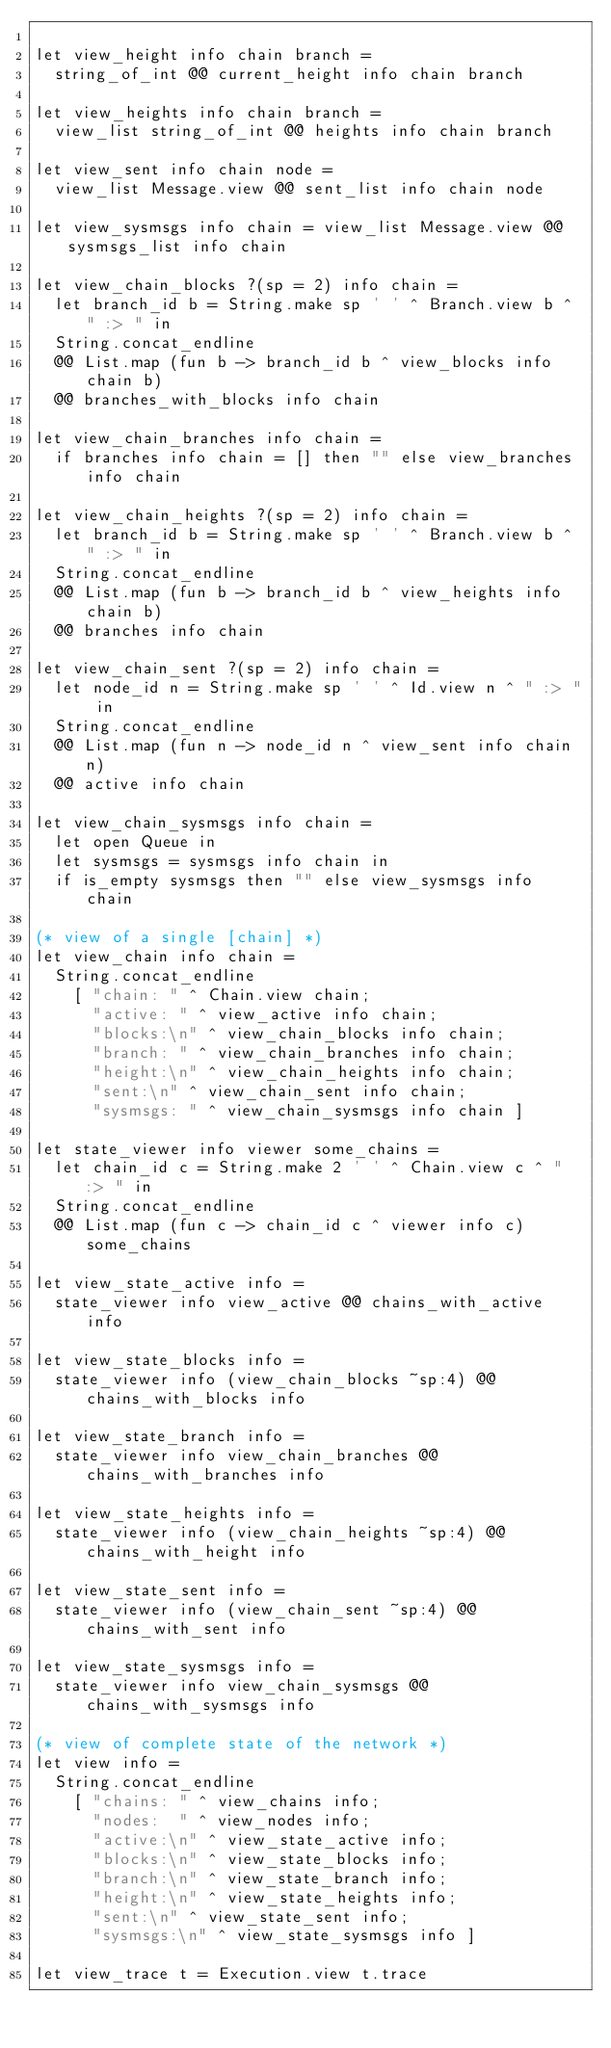<code> <loc_0><loc_0><loc_500><loc_500><_OCaml_>
let view_height info chain branch =
  string_of_int @@ current_height info chain branch

let view_heights info chain branch =
  view_list string_of_int @@ heights info chain branch

let view_sent info chain node =
  view_list Message.view @@ sent_list info chain node

let view_sysmsgs info chain = view_list Message.view @@ sysmsgs_list info chain

let view_chain_blocks ?(sp = 2) info chain =
  let branch_id b = String.make sp ' ' ^ Branch.view b ^ " :> " in
  String.concat_endline
  @@ List.map (fun b -> branch_id b ^ view_blocks info chain b)
  @@ branches_with_blocks info chain

let view_chain_branches info chain =
  if branches info chain = [] then "" else view_branches info chain

let view_chain_heights ?(sp = 2) info chain =
  let branch_id b = String.make sp ' ' ^ Branch.view b ^ " :> " in
  String.concat_endline
  @@ List.map (fun b -> branch_id b ^ view_heights info chain b)
  @@ branches info chain

let view_chain_sent ?(sp = 2) info chain =
  let node_id n = String.make sp ' ' ^ Id.view n ^ " :> " in
  String.concat_endline
  @@ List.map (fun n -> node_id n ^ view_sent info chain n)
  @@ active info chain

let view_chain_sysmsgs info chain =
  let open Queue in
  let sysmsgs = sysmsgs info chain in
  if is_empty sysmsgs then "" else view_sysmsgs info chain

(* view of a single [chain] *)
let view_chain info chain =
  String.concat_endline
    [ "chain: " ^ Chain.view chain;
      "active: " ^ view_active info chain;
      "blocks:\n" ^ view_chain_blocks info chain;
      "branch: " ^ view_chain_branches info chain;
      "height:\n" ^ view_chain_heights info chain;
      "sent:\n" ^ view_chain_sent info chain;
      "sysmsgs: " ^ view_chain_sysmsgs info chain ]

let state_viewer info viewer some_chains =
  let chain_id c = String.make 2 ' ' ^ Chain.view c ^ " :> " in
  String.concat_endline
  @@ List.map (fun c -> chain_id c ^ viewer info c) some_chains

let view_state_active info =
  state_viewer info view_active @@ chains_with_active info

let view_state_blocks info =
  state_viewer info (view_chain_blocks ~sp:4) @@ chains_with_blocks info

let view_state_branch info =
  state_viewer info view_chain_branches @@ chains_with_branches info

let view_state_heights info =
  state_viewer info (view_chain_heights ~sp:4) @@ chains_with_height info

let view_state_sent info =
  state_viewer info (view_chain_sent ~sp:4) @@ chains_with_sent info

let view_state_sysmsgs info =
  state_viewer info view_chain_sysmsgs @@ chains_with_sysmsgs info

(* view of complete state of the network *)
let view info =
  String.concat_endline
    [ "chains: " ^ view_chains info;
      "nodes:  " ^ view_nodes info;
      "active:\n" ^ view_state_active info;
      "blocks:\n" ^ view_state_blocks info;
      "branch:\n" ^ view_state_branch info;
      "height:\n" ^ view_state_heights info;
      "sent:\n" ^ view_state_sent info;
      "sysmsgs:\n" ^ view_state_sysmsgs info ]

let view_trace t = Execution.view t.trace
</code> 